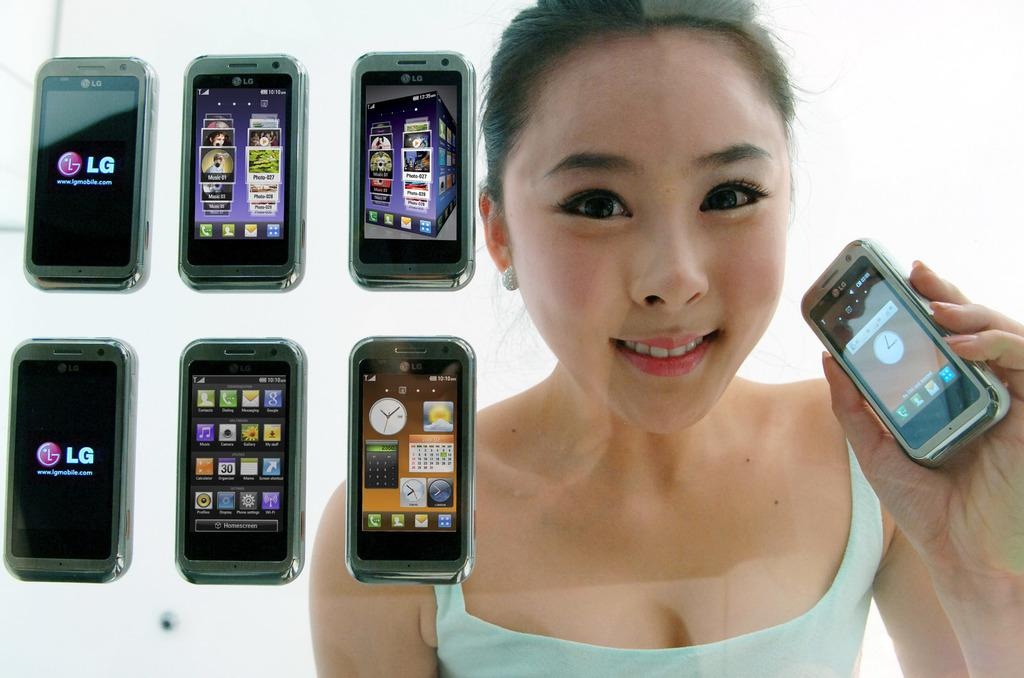<image>
Share a concise interpretation of the image provided. A women in a tank top holding a black cell phone and smiling and six more LG phones placed next to her. 